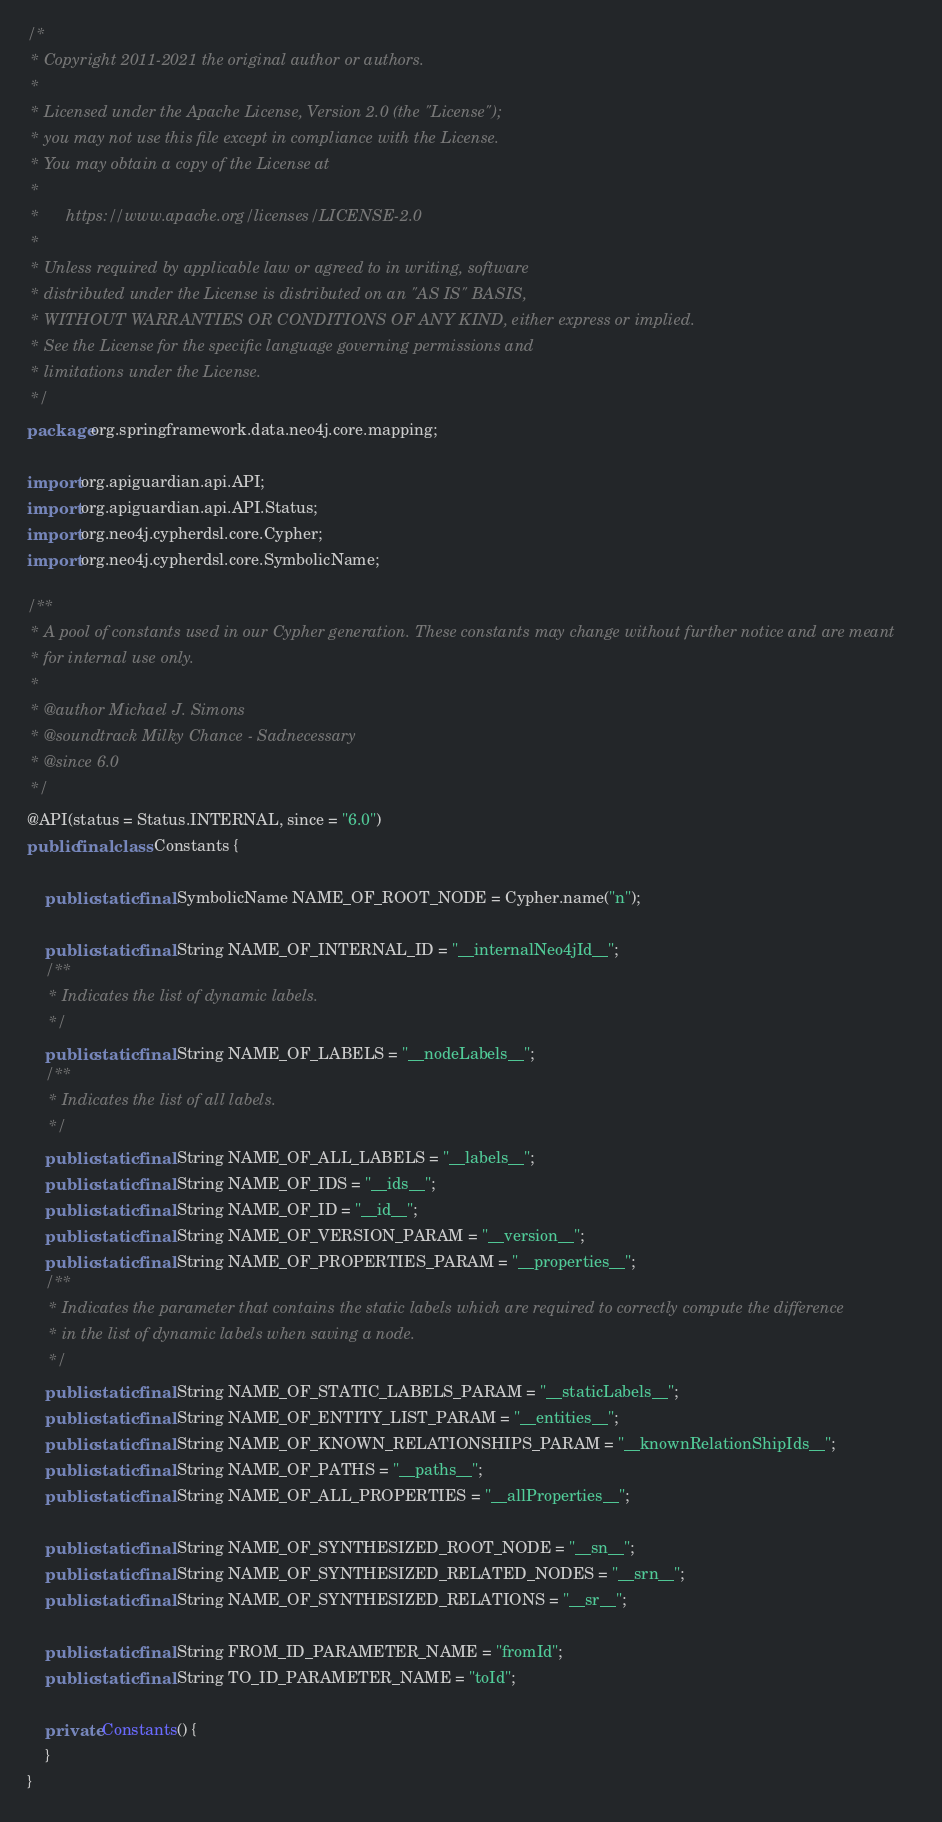<code> <loc_0><loc_0><loc_500><loc_500><_Java_>/*
 * Copyright 2011-2021 the original author or authors.
 *
 * Licensed under the Apache License, Version 2.0 (the "License");
 * you may not use this file except in compliance with the License.
 * You may obtain a copy of the License at
 *
 *      https://www.apache.org/licenses/LICENSE-2.0
 *
 * Unless required by applicable law or agreed to in writing, software
 * distributed under the License is distributed on an "AS IS" BASIS,
 * WITHOUT WARRANTIES OR CONDITIONS OF ANY KIND, either express or implied.
 * See the License for the specific language governing permissions and
 * limitations under the License.
 */
package org.springframework.data.neo4j.core.mapping;

import org.apiguardian.api.API;
import org.apiguardian.api.API.Status;
import org.neo4j.cypherdsl.core.Cypher;
import org.neo4j.cypherdsl.core.SymbolicName;

/**
 * A pool of constants used in our Cypher generation. These constants may change without further notice and are meant
 * for internal use only.
 *
 * @author Michael J. Simons
 * @soundtrack Milky Chance - Sadnecessary
 * @since 6.0
 */
@API(status = Status.INTERNAL, since = "6.0")
public final class Constants {

	public static final SymbolicName NAME_OF_ROOT_NODE = Cypher.name("n");

	public static final String NAME_OF_INTERNAL_ID = "__internalNeo4jId__";
	/**
	 * Indicates the list of dynamic labels.
	 */
	public static final String NAME_OF_LABELS = "__nodeLabels__";
	/**
	 * Indicates the list of all labels.
	 */
	public static final String NAME_OF_ALL_LABELS = "__labels__";
	public static final String NAME_OF_IDS = "__ids__";
	public static final String NAME_OF_ID = "__id__";
	public static final String NAME_OF_VERSION_PARAM = "__version__";
	public static final String NAME_OF_PROPERTIES_PARAM = "__properties__";
	/**
	 * Indicates the parameter that contains the static labels which are required to correctly compute the difference
	 * in the list of dynamic labels when saving a node.
	 */
	public static final String NAME_OF_STATIC_LABELS_PARAM = "__staticLabels__";
	public static final String NAME_OF_ENTITY_LIST_PARAM = "__entities__";
	public static final String NAME_OF_KNOWN_RELATIONSHIPS_PARAM = "__knownRelationShipIds__";
	public static final String NAME_OF_PATHS = "__paths__";
	public static final String NAME_OF_ALL_PROPERTIES = "__allProperties__";

	public static final String NAME_OF_SYNTHESIZED_ROOT_NODE = "__sn__";
	public static final String NAME_OF_SYNTHESIZED_RELATED_NODES = "__srn__";
	public static final String NAME_OF_SYNTHESIZED_RELATIONS = "__sr__";

	public static final String FROM_ID_PARAMETER_NAME = "fromId";
	public static final String TO_ID_PARAMETER_NAME = "toId";

	private Constants() {
	}
}
</code> 